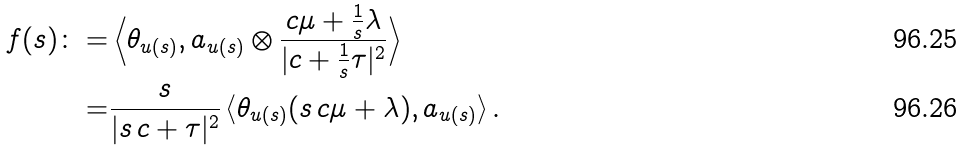<formula> <loc_0><loc_0><loc_500><loc_500>f ( s ) \colon = & \left \langle \theta _ { u ( s ) } , a _ { u ( s ) } \otimes \frac { c \mu + \frac { 1 } { s } \lambda } { | c + \frac { 1 } { s } \tau | ^ { 2 } } \right \rangle \\ = & \frac { s } { | s \, c + \tau | ^ { 2 } } \left \langle \theta _ { u ( s ) } ( s \, c \mu + \lambda ) , a _ { u ( s ) } \right \rangle .</formula> 